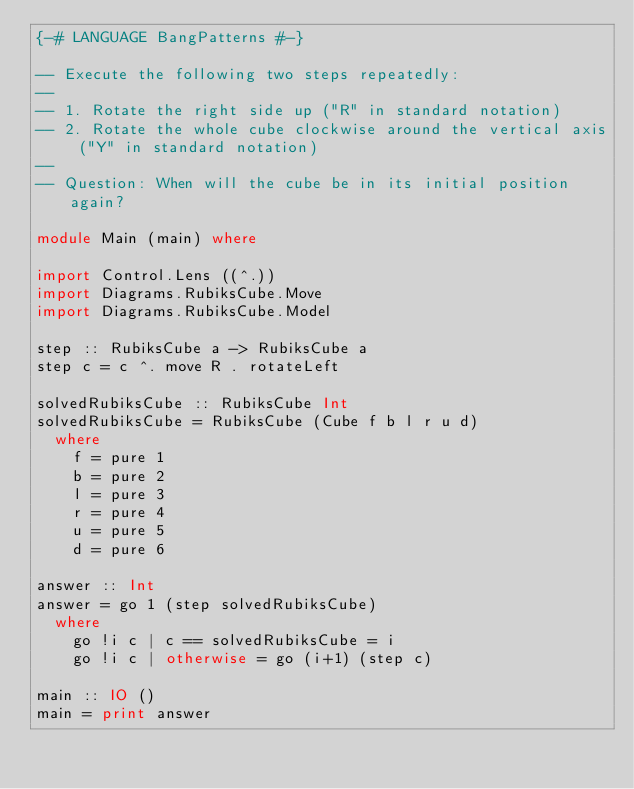<code> <loc_0><loc_0><loc_500><loc_500><_Haskell_>{-# LANGUAGE BangPatterns #-}

-- Execute the following two steps repeatedly:
--
-- 1. Rotate the right side up ("R" in standard notation)
-- 2. Rotate the whole cube clockwise around the vertical axis ("Y" in standard notation)
--
-- Question: When will the cube be in its initial position again?

module Main (main) where

import Control.Lens ((^.))
import Diagrams.RubiksCube.Move
import Diagrams.RubiksCube.Model

step :: RubiksCube a -> RubiksCube a
step c = c ^. move R . rotateLeft

solvedRubiksCube :: RubiksCube Int
solvedRubiksCube = RubiksCube (Cube f b l r u d)
  where
    f = pure 1
    b = pure 2
    l = pure 3
    r = pure 4
    u = pure 5
    d = pure 6

answer :: Int
answer = go 1 (step solvedRubiksCube)
  where
    go !i c | c == solvedRubiksCube = i
    go !i c | otherwise = go (i+1) (step c)

main :: IO ()
main = print answer</code> 